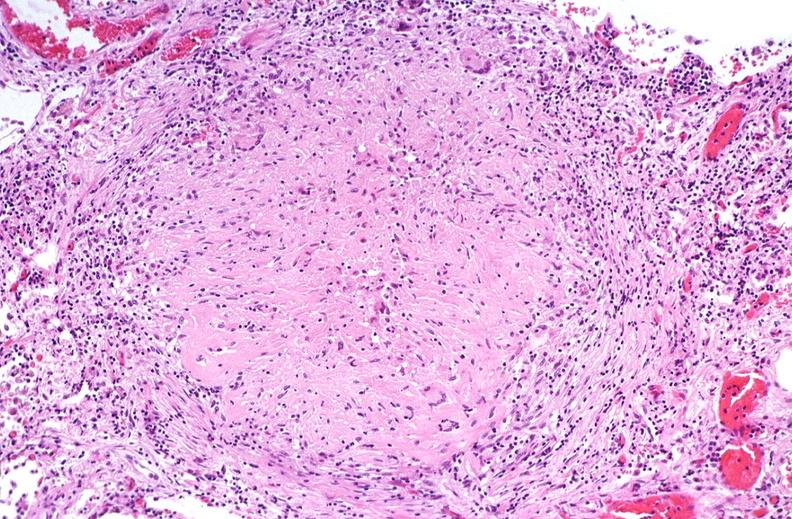what is present?
Answer the question using a single word or phrase. Respiratory 